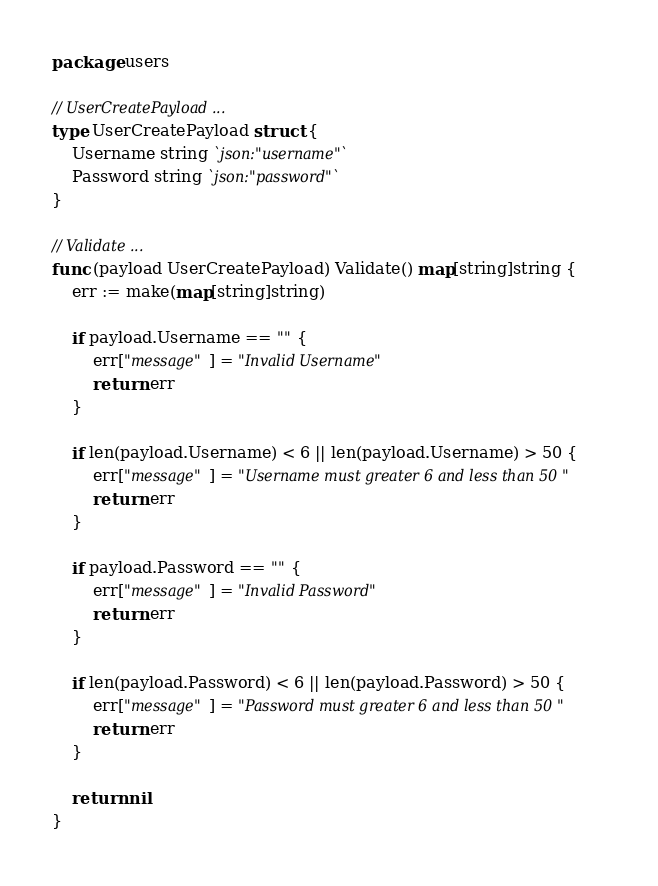Convert code to text. <code><loc_0><loc_0><loc_500><loc_500><_Go_>package users

// UserCreatePayload ...
type UserCreatePayload struct {
	Username string `json:"username"`
	Password string `json:"password"`
}

// Validate ...
func (payload UserCreatePayload) Validate() map[string]string {
	err := make(map[string]string)

	if payload.Username == "" {
		err["message"] = "Invalid Username"
		return err
	}

	if len(payload.Username) < 6 || len(payload.Username) > 50 {
		err["message"] = "Username must greater 6 and less than 50 "
		return err
	}

	if payload.Password == "" {
		err["message"] = "Invalid Password"
		return err
	}

	if len(payload.Password) < 6 || len(payload.Password) > 50 {
		err["message"] = "Password must greater 6 and less than 50 "
		return err
	}

	return nil
}
</code> 